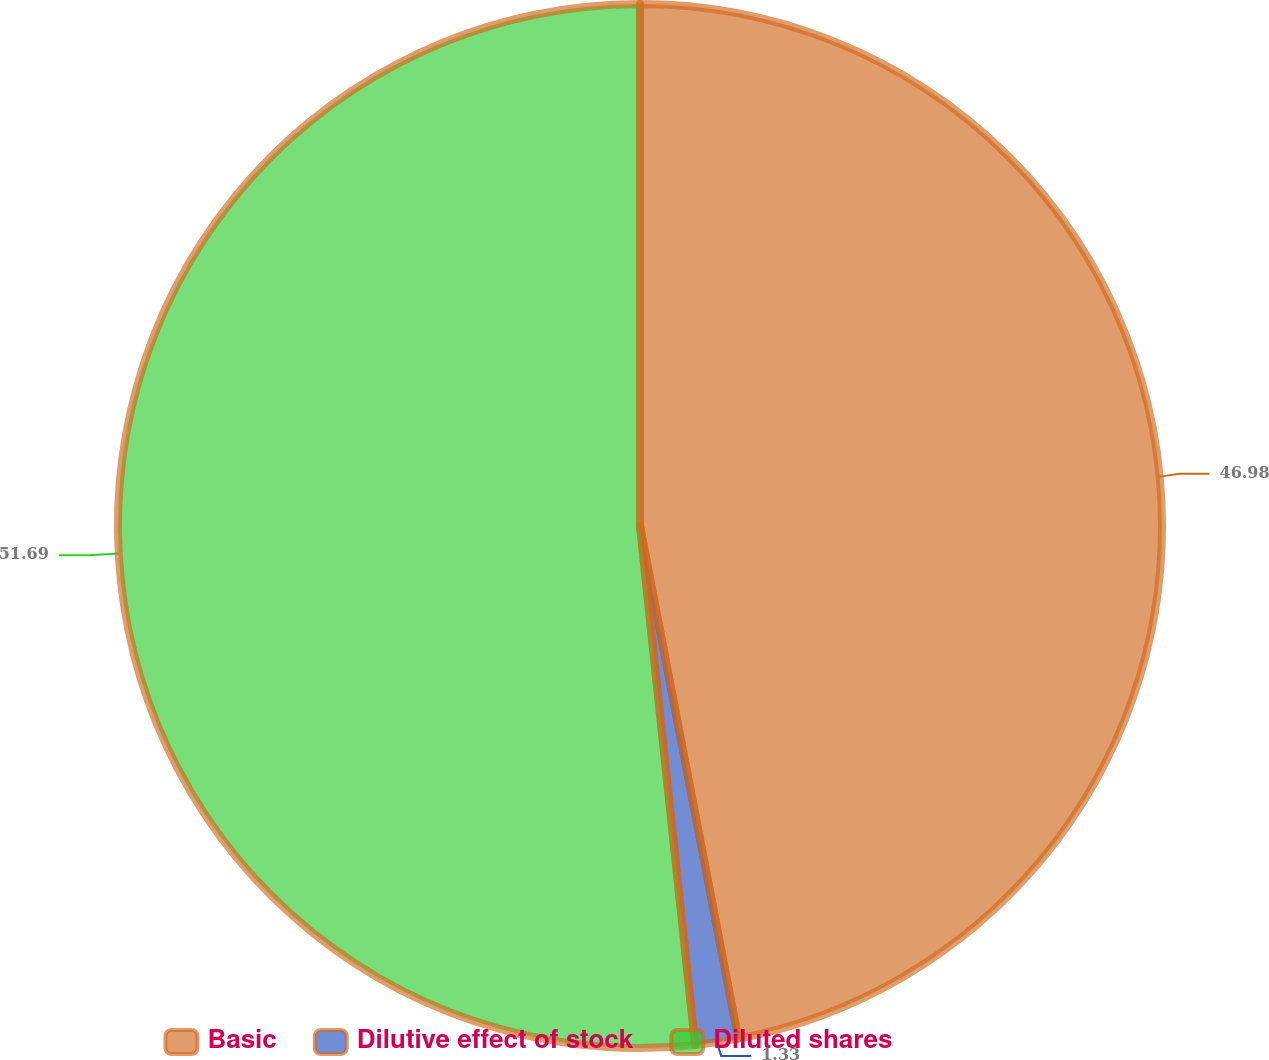<chart> <loc_0><loc_0><loc_500><loc_500><pie_chart><fcel>Basic<fcel>Dilutive effect of stock<fcel>Diluted shares<nl><fcel>46.98%<fcel>1.33%<fcel>51.68%<nl></chart> 